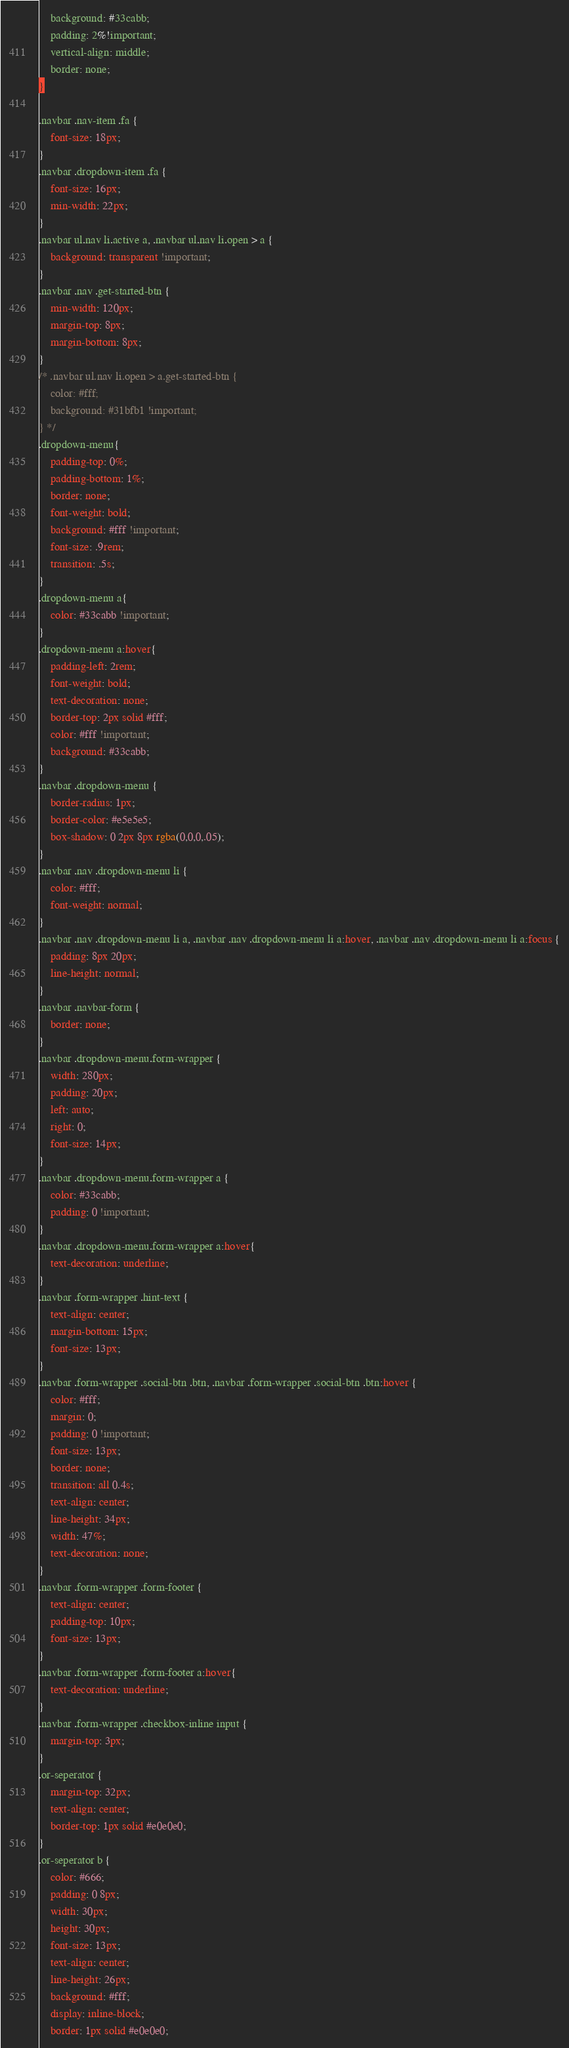Convert code to text. <code><loc_0><loc_0><loc_500><loc_500><_CSS_>    background: #33cabb;
    padding: 2%!important;
    vertical-align: middle;
    border: none;
}	

.navbar .nav-item .fa {
    font-size: 18px;
}
.navbar .dropdown-item .fa {
    font-size: 16px;
    min-width: 22px;
}
.navbar ul.nav li.active a, .navbar ul.nav li.open > a {
    background: transparent !important;
}	
.navbar .nav .get-started-btn {
    min-width: 120px;
    margin-top: 8px;
    margin-bottom: 8px;
}
/* .navbar ul.nav li.open > a.get-started-btn {
    color: #fff;
    background: #31bfb1 !important;
} */
.dropdown-menu{
    padding-top: 0%;
    padding-bottom: 1%;
    border: none;
    font-weight: bold;
    background: #fff !important;
    font-size: .9rem;
    transition: .5s;
}
.dropdown-menu a{
    color: #33cabb !important;
}
.dropdown-menu a:hover{
    padding-left: 2rem;
    font-weight: bold;
    text-decoration: none;
    border-top: 2px solid #fff;
    color: #fff !important;
    background: #33cabb;
}
.navbar .dropdown-menu {
    border-radius: 1px;
    border-color: #e5e5e5;
    box-shadow: 0 2px 8px rgba(0,0,0,.05);
}
.navbar .nav .dropdown-menu li {
    color: #fff;
    font-weight: normal;
}
.navbar .nav .dropdown-menu li a, .navbar .nav .dropdown-menu li a:hover, .navbar .nav .dropdown-menu li a:focus {
    padding: 8px 20px;
    line-height: normal;
}
.navbar .navbar-form {
    border: none;
}
.navbar .dropdown-menu.form-wrapper {
    width: 280px;
    padding: 20px;
    left: auto;
    right: 0;
    font-size: 14px;
}
.navbar .dropdown-menu.form-wrapper a {		
    color: #33cabb;
    padding: 0 !important;
}
.navbar .dropdown-menu.form-wrapper a:hover{
    text-decoration: underline;
}
.navbar .form-wrapper .hint-text {
    text-align: center;
    margin-bottom: 15px;
    font-size: 13px;
}
.navbar .form-wrapper .social-btn .btn, .navbar .form-wrapper .social-btn .btn:hover {
    color: #fff;
    margin: 0;
    padding: 0 !important;
    font-size: 13px;
    border: none;
    transition: all 0.4s;
    text-align: center;
    line-height: 34px;
    width: 47%;
    text-decoration: none;
}	
.navbar .form-wrapper .form-footer {
    text-align: center;
    padding-top: 10px;
    font-size: 13px;
}
.navbar .form-wrapper .form-footer a:hover{
    text-decoration: underline;
}
.navbar .form-wrapper .checkbox-inline input {
    margin-top: 3px;
}
.or-seperator {
    margin-top: 32px;
    text-align: center;
    border-top: 1px solid #e0e0e0;
}
.or-seperator b {
    color: #666;
    padding: 0 8px;
    width: 30px;
    height: 30px;
    font-size: 13px;
    text-align: center;
    line-height: 26px;
    background: #fff;
    display: inline-block;
    border: 1px solid #e0e0e0;</code> 